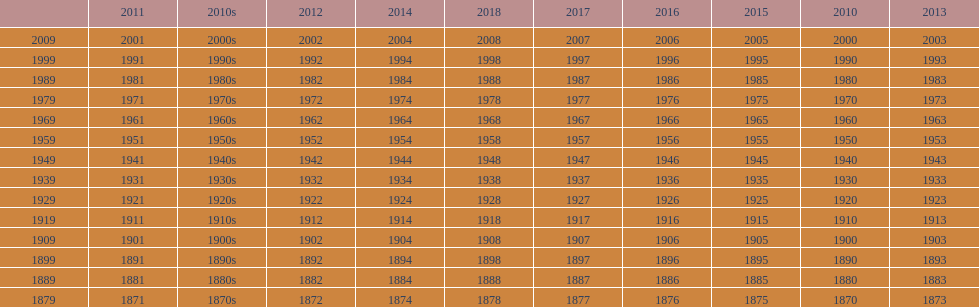Which decade is the only one to have fewer years in its row than the others? 2010s. 